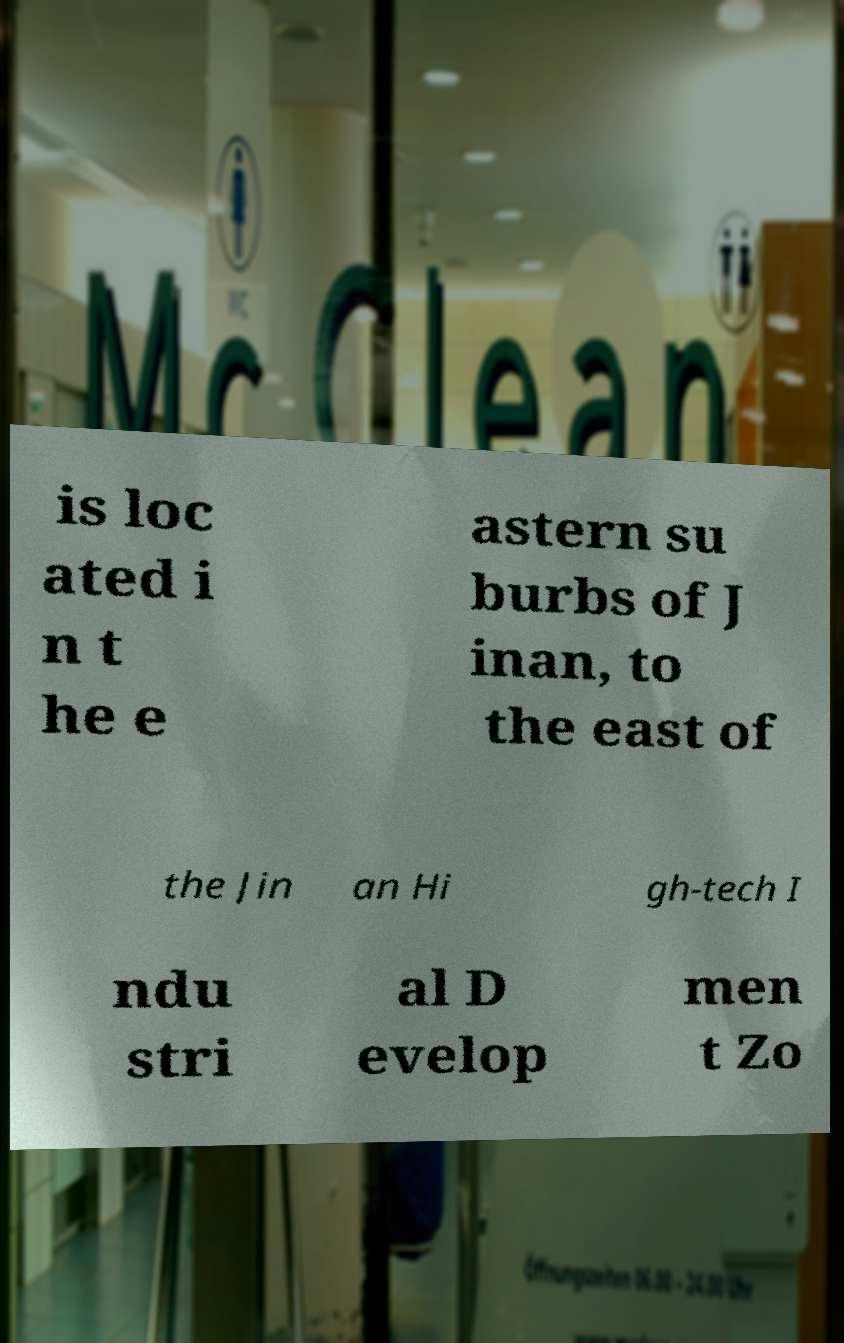For documentation purposes, I need the text within this image transcribed. Could you provide that? is loc ated i n t he e astern su burbs of J inan, to the east of the Jin an Hi gh-tech I ndu stri al D evelop men t Zo 